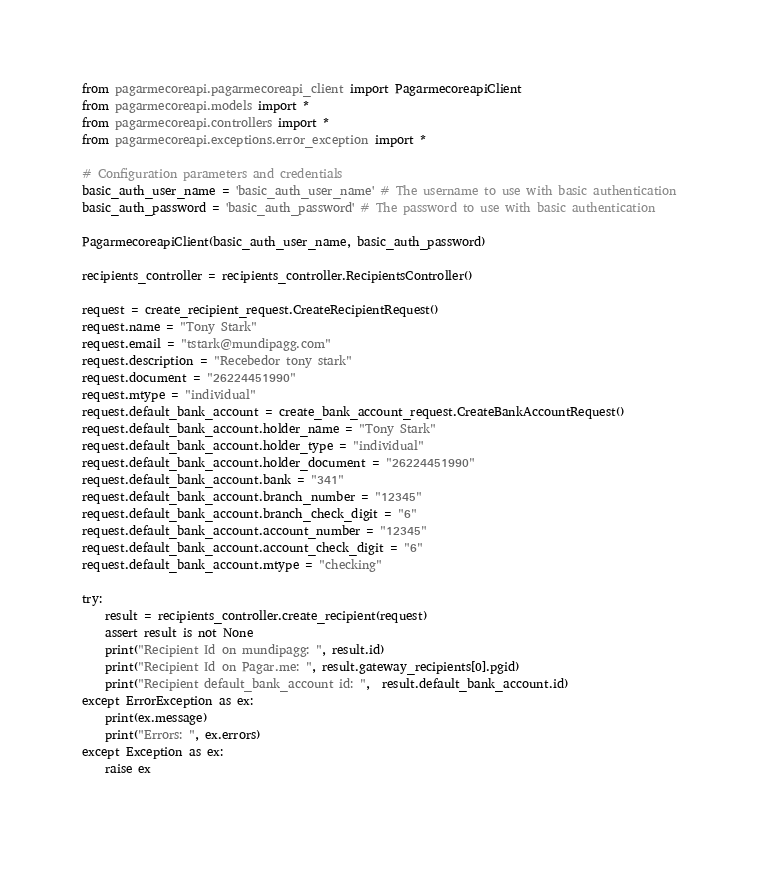Convert code to text. <code><loc_0><loc_0><loc_500><loc_500><_Python_>from pagarmecoreapi.pagarmecoreapi_client import PagarmecoreapiClient
from pagarmecoreapi.models import *
from pagarmecoreapi.controllers import *
from pagarmecoreapi.exceptions.error_exception import *

# Configuration parameters and credentials
basic_auth_user_name = 'basic_auth_user_name' # The username to use with basic authentication
basic_auth_password = 'basic_auth_password' # The password to use with basic authentication

PagarmecoreapiClient(basic_auth_user_name, basic_auth_password)

recipients_controller = recipients_controller.RecipientsController()

request = create_recipient_request.CreateRecipientRequest()
request.name = "Tony Stark"
request.email = "tstark@mundipagg.com"
request.description = "Recebedor tony stark"
request.document = "26224451990"
request.mtype = "individual"
request.default_bank_account = create_bank_account_request.CreateBankAccountRequest()
request.default_bank_account.holder_name = "Tony Stark"
request.default_bank_account.holder_type = "individual"
request.default_bank_account.holder_document = "26224451990"
request.default_bank_account.bank = "341"
request.default_bank_account.branch_number = "12345"
request.default_bank_account.branch_check_digit = "6"
request.default_bank_account.account_number = "12345"
request.default_bank_account.account_check_digit = "6"
request.default_bank_account.mtype = "checking"

try:
    result = recipients_controller.create_recipient(request)
    assert result is not None
    print("Recipient Id on mundipagg: ", result.id)
    print("Recipient Id on Pagar.me: ", result.gateway_recipients[0].pgid)
    print("Recipient default_bank_account id: ",  result.default_bank_account.id)
except ErrorException as ex:
    print(ex.message)
    print("Errors: ", ex.errors)
except Exception as ex:
    raise ex
    </code> 